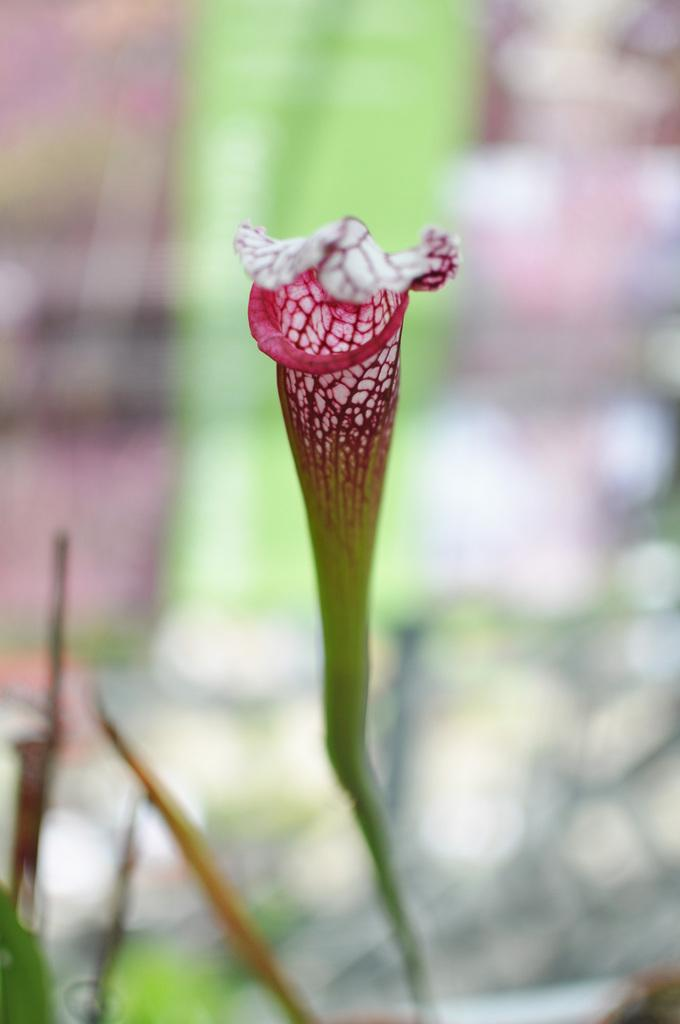What is the main subject of the image? There is a flower in the image. Can you describe any specific features of the flower? The flower has a stem. What can be observed about the background of the image? The background of the image is blurred. How many rings are visible on the flower's stem in the image? There are no rings visible on the flower's stem in the image. What type of powder is sprinkled on the flower in the image? There is no powder present on the flower in the image. 